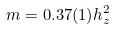Convert formula to latex. <formula><loc_0><loc_0><loc_500><loc_500>m = 0 . 3 7 ( 1 ) h _ { z } ^ { 2 }</formula> 